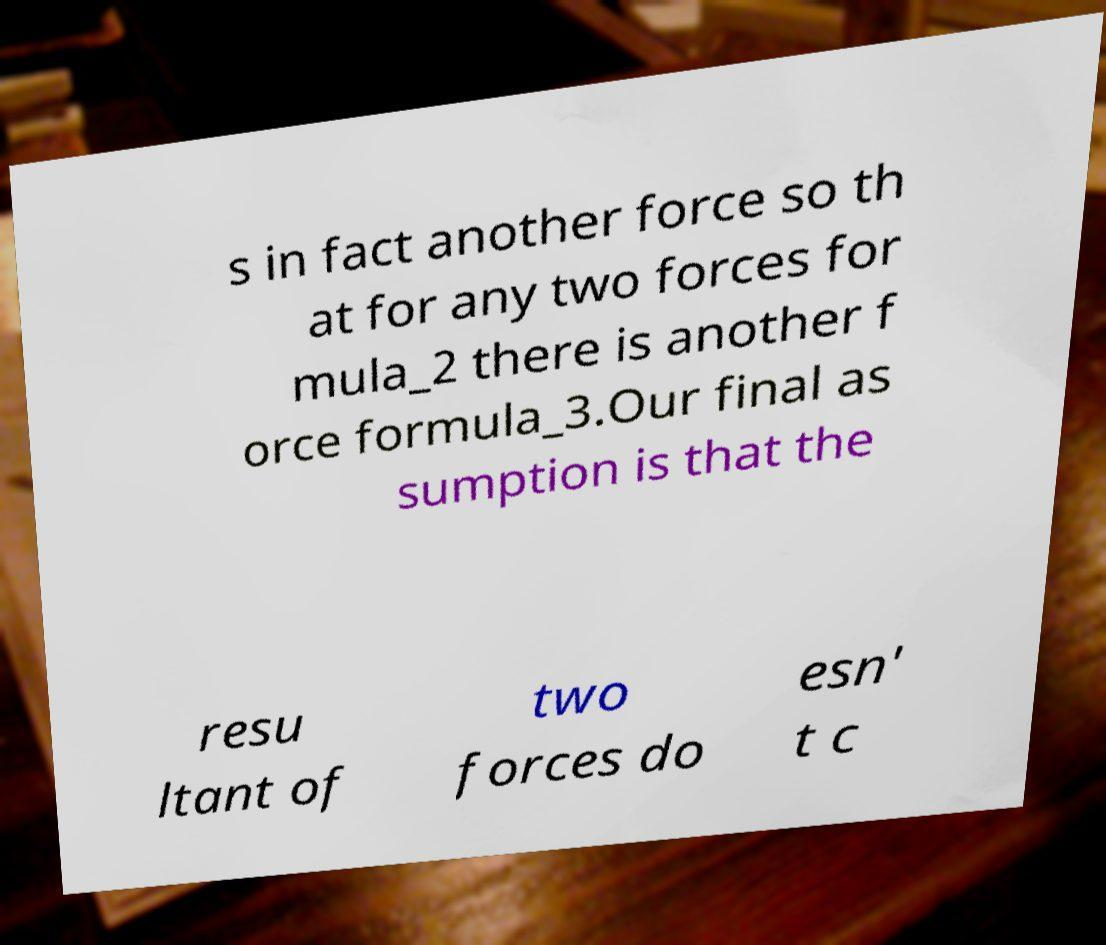For documentation purposes, I need the text within this image transcribed. Could you provide that? s in fact another force so th at for any two forces for mula_2 there is another f orce formula_3.Our final as sumption is that the resu ltant of two forces do esn' t c 